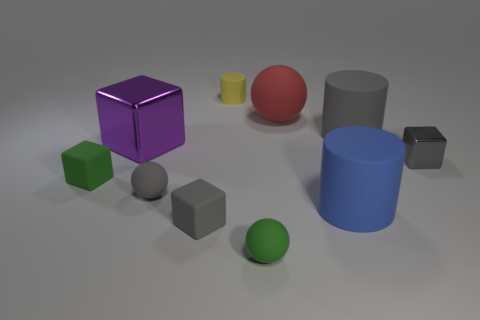Subtract all cylinders. How many objects are left? 7 Subtract 1 blue cylinders. How many objects are left? 9 Subtract all blue objects. Subtract all brown objects. How many objects are left? 9 Add 1 gray blocks. How many gray blocks are left? 3 Add 7 large blue cubes. How many large blue cubes exist? 7 